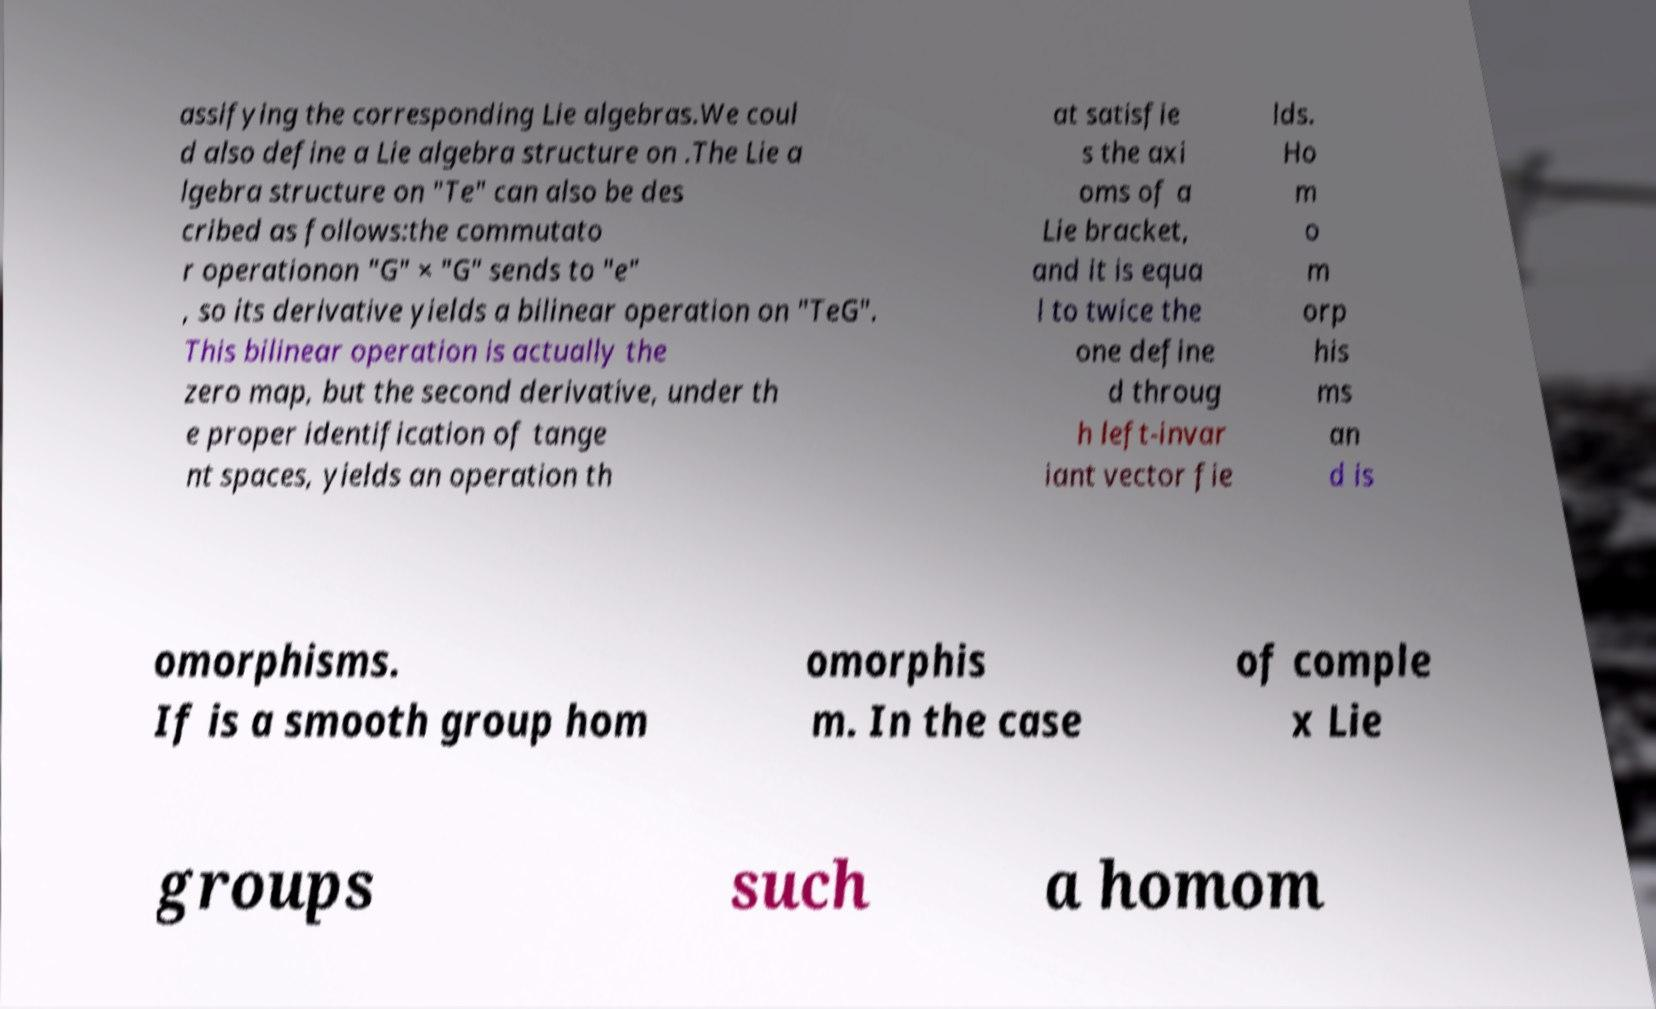I need the written content from this picture converted into text. Can you do that? assifying the corresponding Lie algebras.We coul d also define a Lie algebra structure on .The Lie a lgebra structure on "Te" can also be des cribed as follows:the commutato r operationon "G" × "G" sends to "e" , so its derivative yields a bilinear operation on "TeG". This bilinear operation is actually the zero map, but the second derivative, under th e proper identification of tange nt spaces, yields an operation th at satisfie s the axi oms of a Lie bracket, and it is equa l to twice the one define d throug h left-invar iant vector fie lds. Ho m o m orp his ms an d is omorphisms. If is a smooth group hom omorphis m. In the case of comple x Lie groups such a homom 